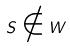<formula> <loc_0><loc_0><loc_500><loc_500>S \notin W</formula> 